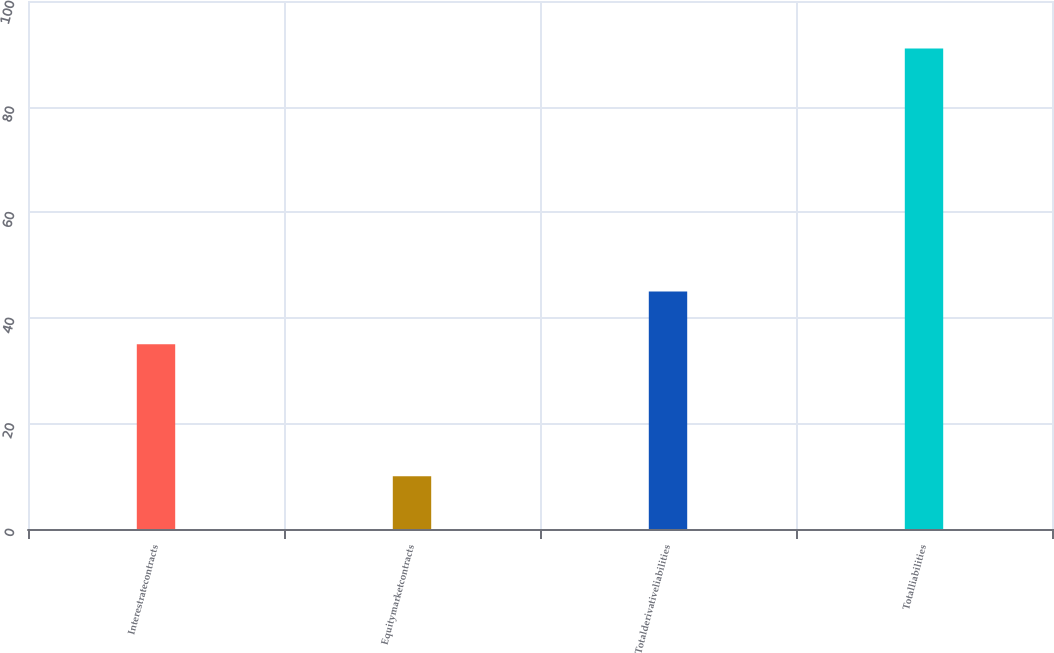Convert chart to OTSL. <chart><loc_0><loc_0><loc_500><loc_500><bar_chart><fcel>Interestratecontracts<fcel>Equitymarketcontracts<fcel>Totalderivativeliabilities<fcel>Totalliabilities<nl><fcel>35<fcel>10<fcel>45<fcel>91<nl></chart> 